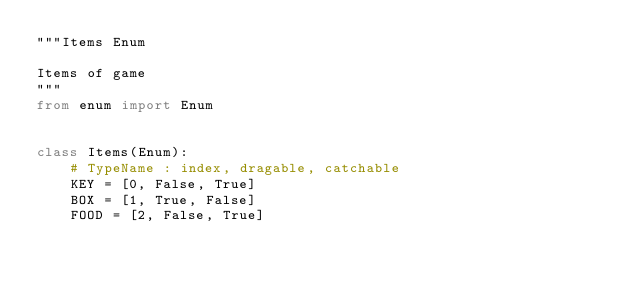<code> <loc_0><loc_0><loc_500><loc_500><_Python_>"""Items Enum

Items of game
"""
from enum import Enum


class Items(Enum):
    # TypeName : index, dragable, catchable
    KEY = [0, False, True]
    BOX = [1, True, False]
    FOOD = [2, False, True]</code> 